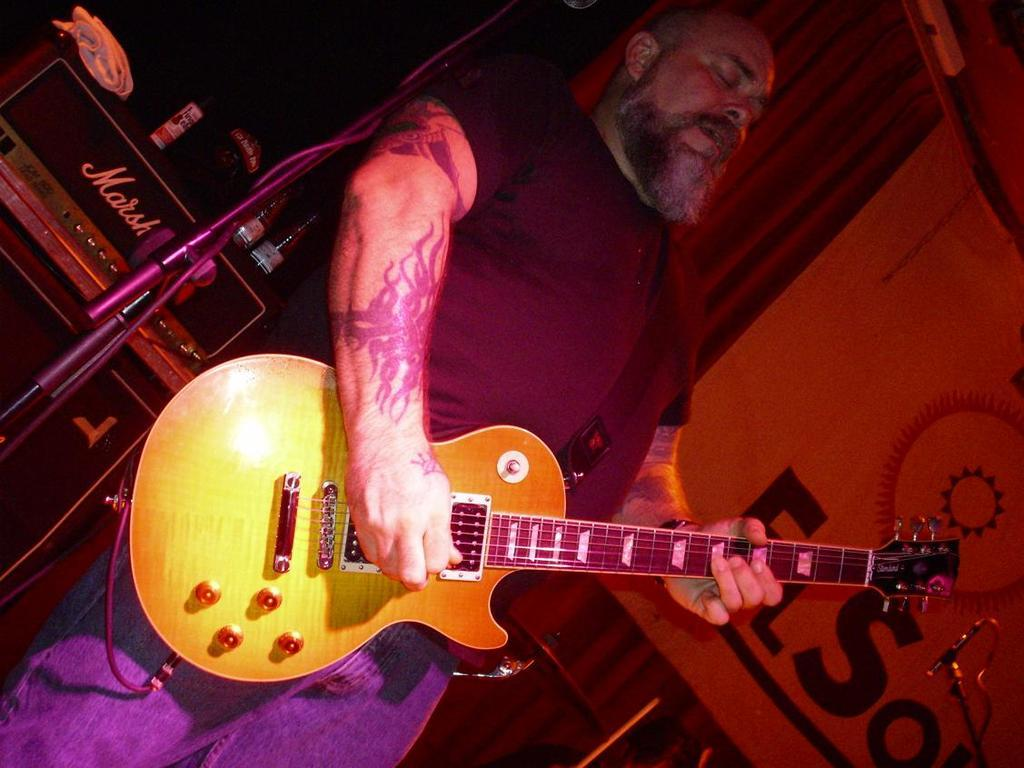What is the main subject of the image? There is a person standing in the image. What is the person doing in the image? The person is playing a musical guitar. What type of club does the person belong to in the image? There is no information about a club or any affiliations in the image. Can you describe the garden where the person is playing the guitar? There is no garden present in the image; it only shows a person playing a guitar. 